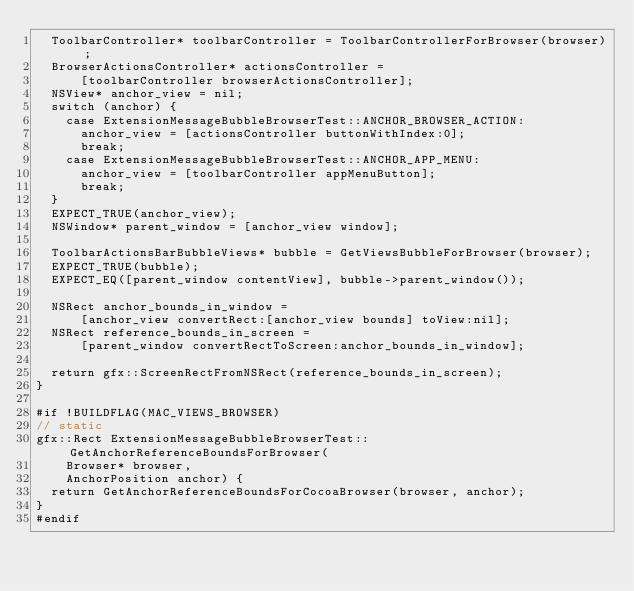Convert code to text. <code><loc_0><loc_0><loc_500><loc_500><_ObjectiveC_>  ToolbarController* toolbarController = ToolbarControllerForBrowser(browser);
  BrowserActionsController* actionsController =
      [toolbarController browserActionsController];
  NSView* anchor_view = nil;
  switch (anchor) {
    case ExtensionMessageBubbleBrowserTest::ANCHOR_BROWSER_ACTION:
      anchor_view = [actionsController buttonWithIndex:0];
      break;
    case ExtensionMessageBubbleBrowserTest::ANCHOR_APP_MENU:
      anchor_view = [toolbarController appMenuButton];
      break;
  }
  EXPECT_TRUE(anchor_view);
  NSWindow* parent_window = [anchor_view window];

  ToolbarActionsBarBubbleViews* bubble = GetViewsBubbleForBrowser(browser);
  EXPECT_TRUE(bubble);
  EXPECT_EQ([parent_window contentView], bubble->parent_window());

  NSRect anchor_bounds_in_window =
      [anchor_view convertRect:[anchor_view bounds] toView:nil];
  NSRect reference_bounds_in_screen =
      [parent_window convertRectToScreen:anchor_bounds_in_window];

  return gfx::ScreenRectFromNSRect(reference_bounds_in_screen);
}

#if !BUILDFLAG(MAC_VIEWS_BROWSER)
// static
gfx::Rect ExtensionMessageBubbleBrowserTest::GetAnchorReferenceBoundsForBrowser(
    Browser* browser,
    AnchorPosition anchor) {
  return GetAnchorReferenceBoundsForCocoaBrowser(browser, anchor);
}
#endif
</code> 